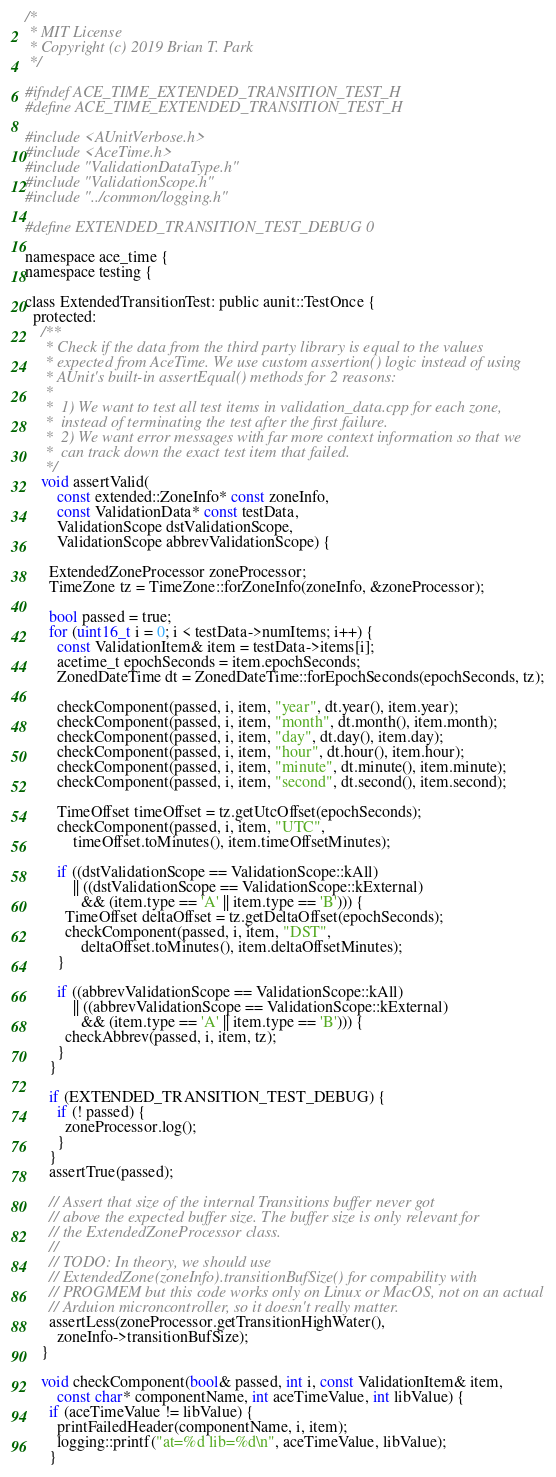<code> <loc_0><loc_0><loc_500><loc_500><_C_>/*
 * MIT License
 * Copyright (c) 2019 Brian T. Park
 */

#ifndef ACE_TIME_EXTENDED_TRANSITION_TEST_H
#define ACE_TIME_EXTENDED_TRANSITION_TEST_H

#include <AUnitVerbose.h>
#include <AceTime.h>
#include "ValidationDataType.h"
#include "ValidationScope.h"
#include "../common/logging.h"

#define EXTENDED_TRANSITION_TEST_DEBUG 0

namespace ace_time {
namespace testing {

class ExtendedTransitionTest: public aunit::TestOnce {
  protected:
    /**
     * Check if the data from the third party library is equal to the values
     * expected from AceTime. We use custom assertion() logic instead of using
     * AUnit's built-in assertEqual() methods for 2 reasons:
     *
     *  1) We want to test all test items in validation_data.cpp for each zone,
     *  instead of terminating the test after the first failure.
     *  2) We want error messages with far more context information so that we
     *  can track down the exact test item that failed.
     */
    void assertValid(
        const extended::ZoneInfo* const zoneInfo,
        const ValidationData* const testData,
        ValidationScope dstValidationScope,
        ValidationScope abbrevValidationScope) {

      ExtendedZoneProcessor zoneProcessor;
      TimeZone tz = TimeZone::forZoneInfo(zoneInfo, &zoneProcessor);

      bool passed = true;
      for (uint16_t i = 0; i < testData->numItems; i++) {
        const ValidationItem& item = testData->items[i];
        acetime_t epochSeconds = item.epochSeconds;
        ZonedDateTime dt = ZonedDateTime::forEpochSeconds(epochSeconds, tz);

        checkComponent(passed, i, item, "year", dt.year(), item.year);
        checkComponent(passed, i, item, "month", dt.month(), item.month);
        checkComponent(passed, i, item, "day", dt.day(), item.day);
        checkComponent(passed, i, item, "hour", dt.hour(), item.hour);
        checkComponent(passed, i, item, "minute", dt.minute(), item.minute);
        checkComponent(passed, i, item, "second", dt.second(), item.second);

        TimeOffset timeOffset = tz.getUtcOffset(epochSeconds);
        checkComponent(passed, i, item, "UTC",
            timeOffset.toMinutes(), item.timeOffsetMinutes);

        if ((dstValidationScope == ValidationScope::kAll)
            || ((dstValidationScope == ValidationScope::kExternal)
              && (item.type == 'A' || item.type == 'B'))) {
          TimeOffset deltaOffset = tz.getDeltaOffset(epochSeconds);
          checkComponent(passed, i, item, "DST",
              deltaOffset.toMinutes(), item.deltaOffsetMinutes);
        }

        if ((abbrevValidationScope == ValidationScope::kAll)
            || ((abbrevValidationScope == ValidationScope::kExternal)
              && (item.type == 'A' || item.type == 'B'))) {
          checkAbbrev(passed, i, item, tz);
        }
      }

      if (EXTENDED_TRANSITION_TEST_DEBUG) {
        if (! passed) {
          zoneProcessor.log();
        }
      }
      assertTrue(passed);

      // Assert that size of the internal Transitions buffer never got
      // above the expected buffer size. The buffer size is only relevant for
      // the ExtendedZoneProcessor class.
      //
      // TODO: In theory, we should use
      // ExtendedZone(zoneInfo).transitionBufSize() for compability with
      // PROGMEM but this code works only on Linux or MacOS, not on an actual
      // Arduion microncontroller, so it doesn't really matter.
      assertLess(zoneProcessor.getTransitionHighWater(),
        zoneInfo->transitionBufSize);
    }

    void checkComponent(bool& passed, int i, const ValidationItem& item,
        const char* componentName, int aceTimeValue, int libValue) {
      if (aceTimeValue != libValue) {
        printFailedHeader(componentName, i, item);
        logging::printf("at=%d lib=%d\n", aceTimeValue, libValue);
      }</code> 